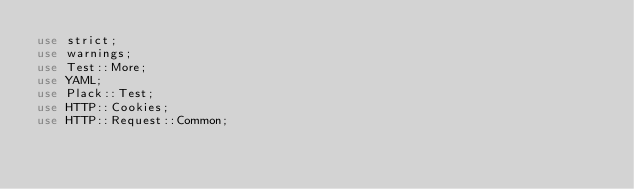<code> <loc_0><loc_0><loc_500><loc_500><_Perl_>use strict;
use warnings;
use Test::More;
use YAML;
use Plack::Test;
use HTTP::Cookies;
use HTTP::Request::Common;
</code> 